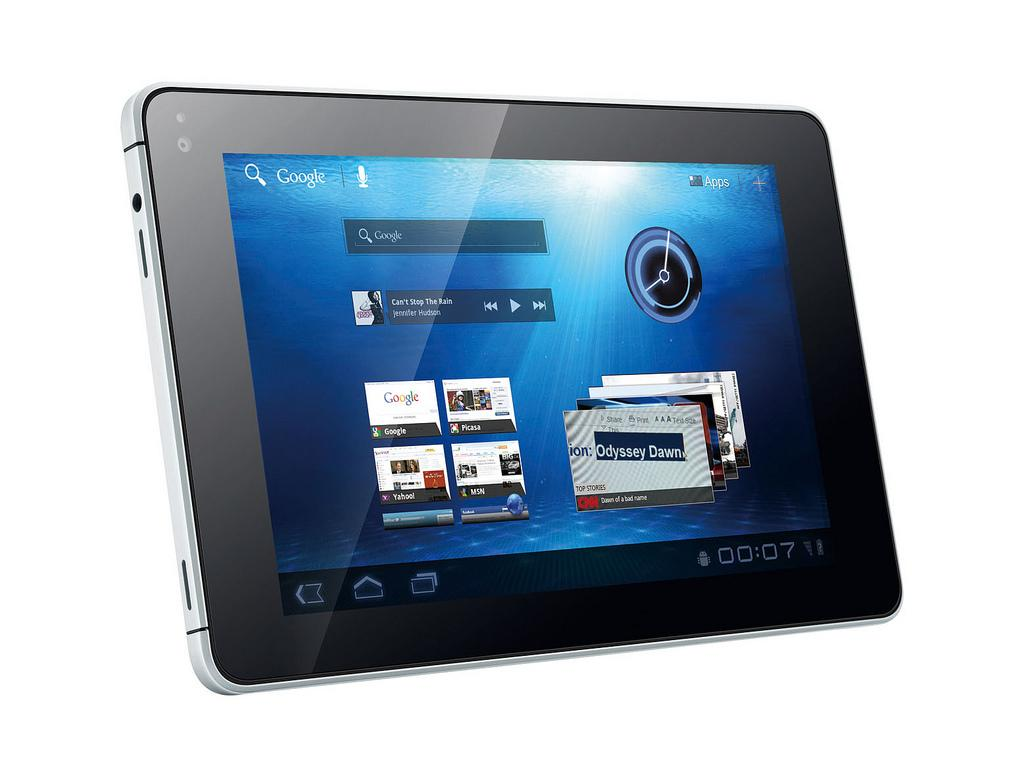What is the main subject of the image? The main subject of the image is a tab. Where is the bedroom located in the image? There is no bedroom present in the image; the main subject is a tab. What shape is the circle in the image? There is no circle present in the image; the main subject is a tab. 